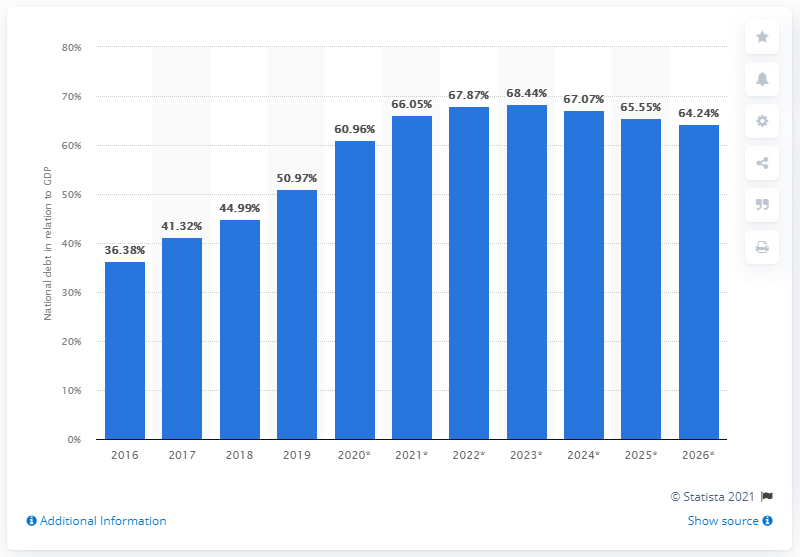Point out several critical features in this image. In 2019, the national debt of Rwanda accounted for approximately 50.97% of the country's Gross Domestic Product (GDP). 